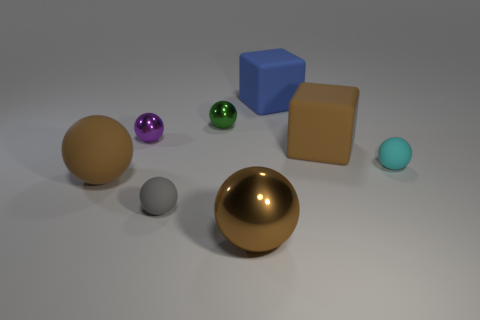Subtract all gray spheres. How many spheres are left? 5 Subtract all tiny green metal balls. How many balls are left? 5 Subtract 2 spheres. How many spheres are left? 4 Subtract all green balls. Subtract all red cylinders. How many balls are left? 5 Add 1 tiny metallic balls. How many objects exist? 9 Subtract all cubes. How many objects are left? 6 Add 3 small spheres. How many small spheres exist? 7 Subtract 1 cyan spheres. How many objects are left? 7 Subtract all large shiny cubes. Subtract all small purple metal things. How many objects are left? 7 Add 4 big matte objects. How many big matte objects are left? 7 